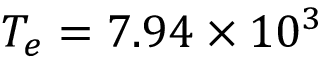<formula> <loc_0><loc_0><loc_500><loc_500>T _ { e } = 7 . 9 4 \times 1 0 ^ { 3 }</formula> 